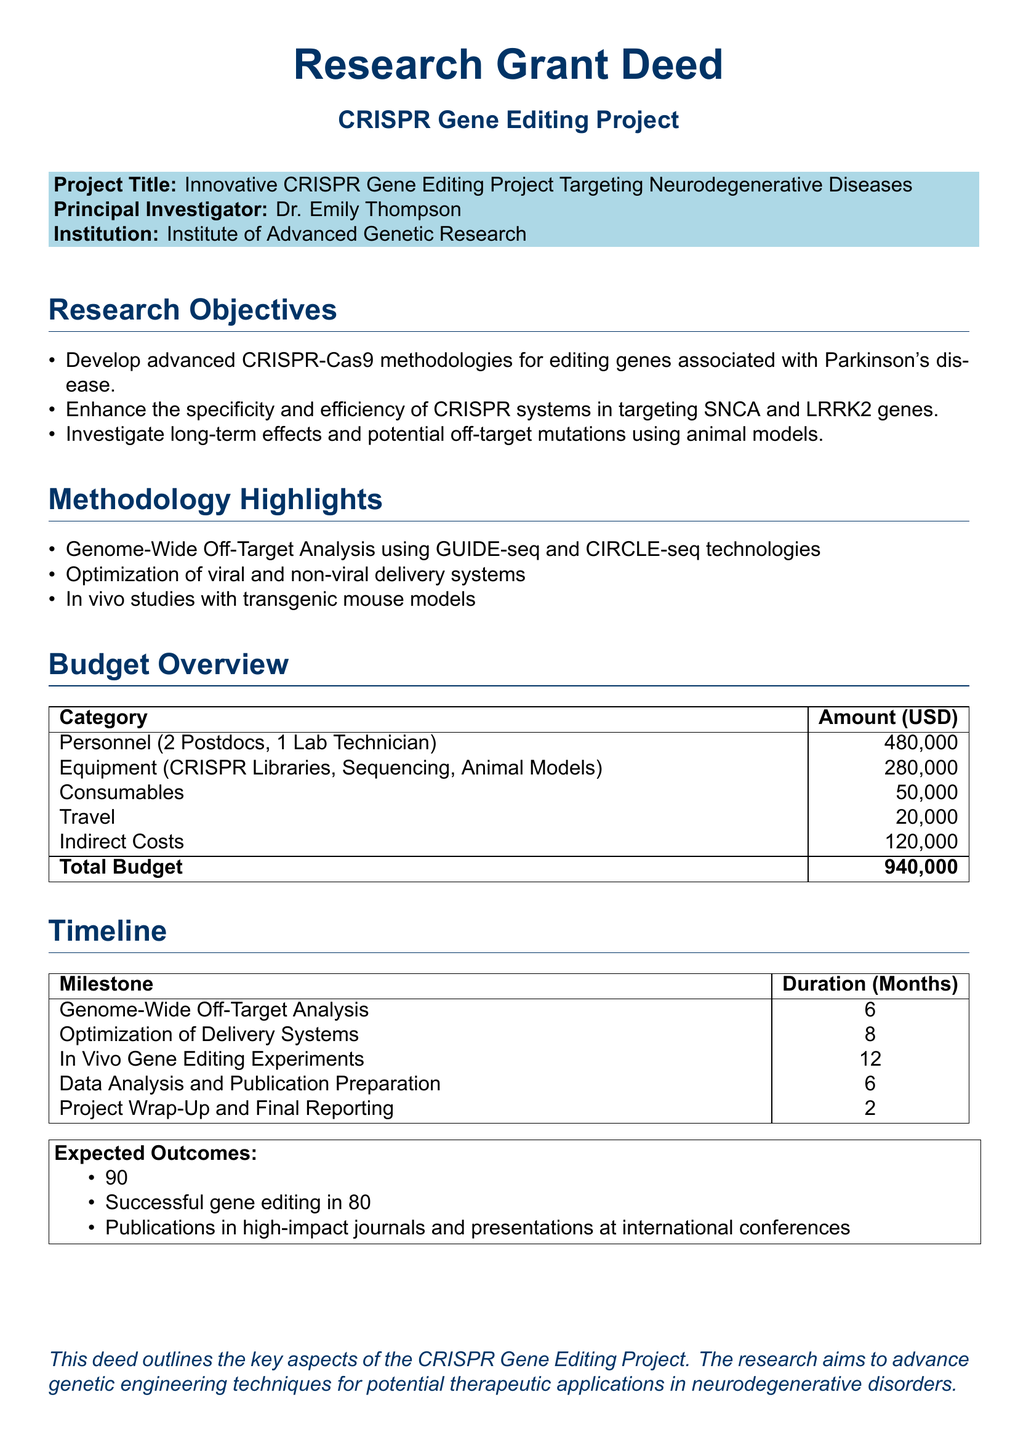What is the project title? The project title is specified under the "Project Title" section in the document.
Answer: Innovative CRISPR Gene Editing Project Targeting Neurodegenerative Diseases Who is the principal investigator? The principal investigator's name is mentioned at the beginning of the document.
Answer: Dr. Emily Thompson What is the total budget? The total budget is calculated by summing all budget categories in the "Budget Overview" table.
Answer: 940,000 How many months is allocated for "In Vivo Gene Editing Experiments"? The duration for this milestone is detailed in the "Timeline" section of the document.
Answer: 12 What is expected to be reduced by 90%? This percentage refers to a specific outcome mentioned in the "Expected Outcomes" section.
Answer: Off-target mutations Which technology is used for Genome-Wide Off-Target Analysis? The specific technologies used are listed under "Methodology Highlights".
Answer: GUIDE-seq and CIRCLE-seq What category has the highest budgeted amount? This information can be found in the "Budget Overview" table by comparing all categories.
Answer: Personnel How long will the data analysis and publication preparation take? This duration is outlined in the "Timeline" section of the document.
Answer: 6 What is the aim of the research project? The aim of the project is summarized in the introduction.
Answer: Advance genetic engineering techniques for potential therapeutic applications in neurodegenerative disorders 